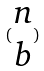Convert formula to latex. <formula><loc_0><loc_0><loc_500><loc_500>( \begin{matrix} n \\ b \end{matrix} )</formula> 